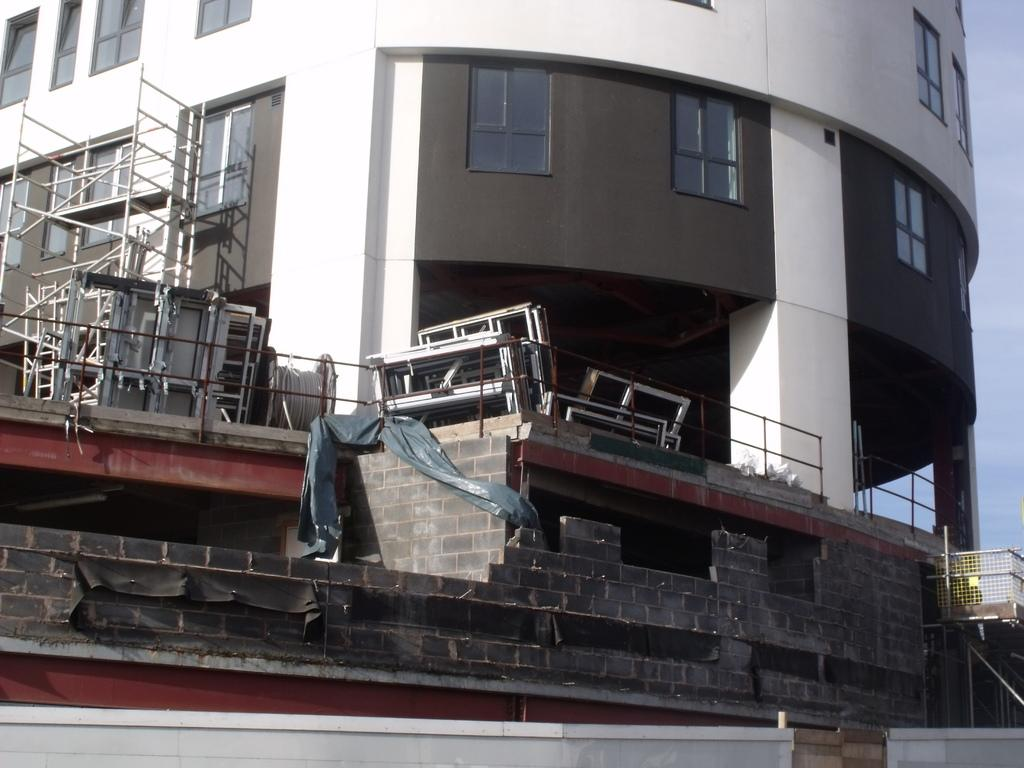What type of structure is present in the image? There is a building in the image. What feature of the building can be observed? The building has multiple windows. What else can be seen in the image besides the building? There are various objects visible in the image. What is the background of the image? The sky is visible in the background of the image. What type of worm can be seen crawling on the disgusting station in the image? There is no worm or station present in the image, and the image does not convey any sense of disgust. 